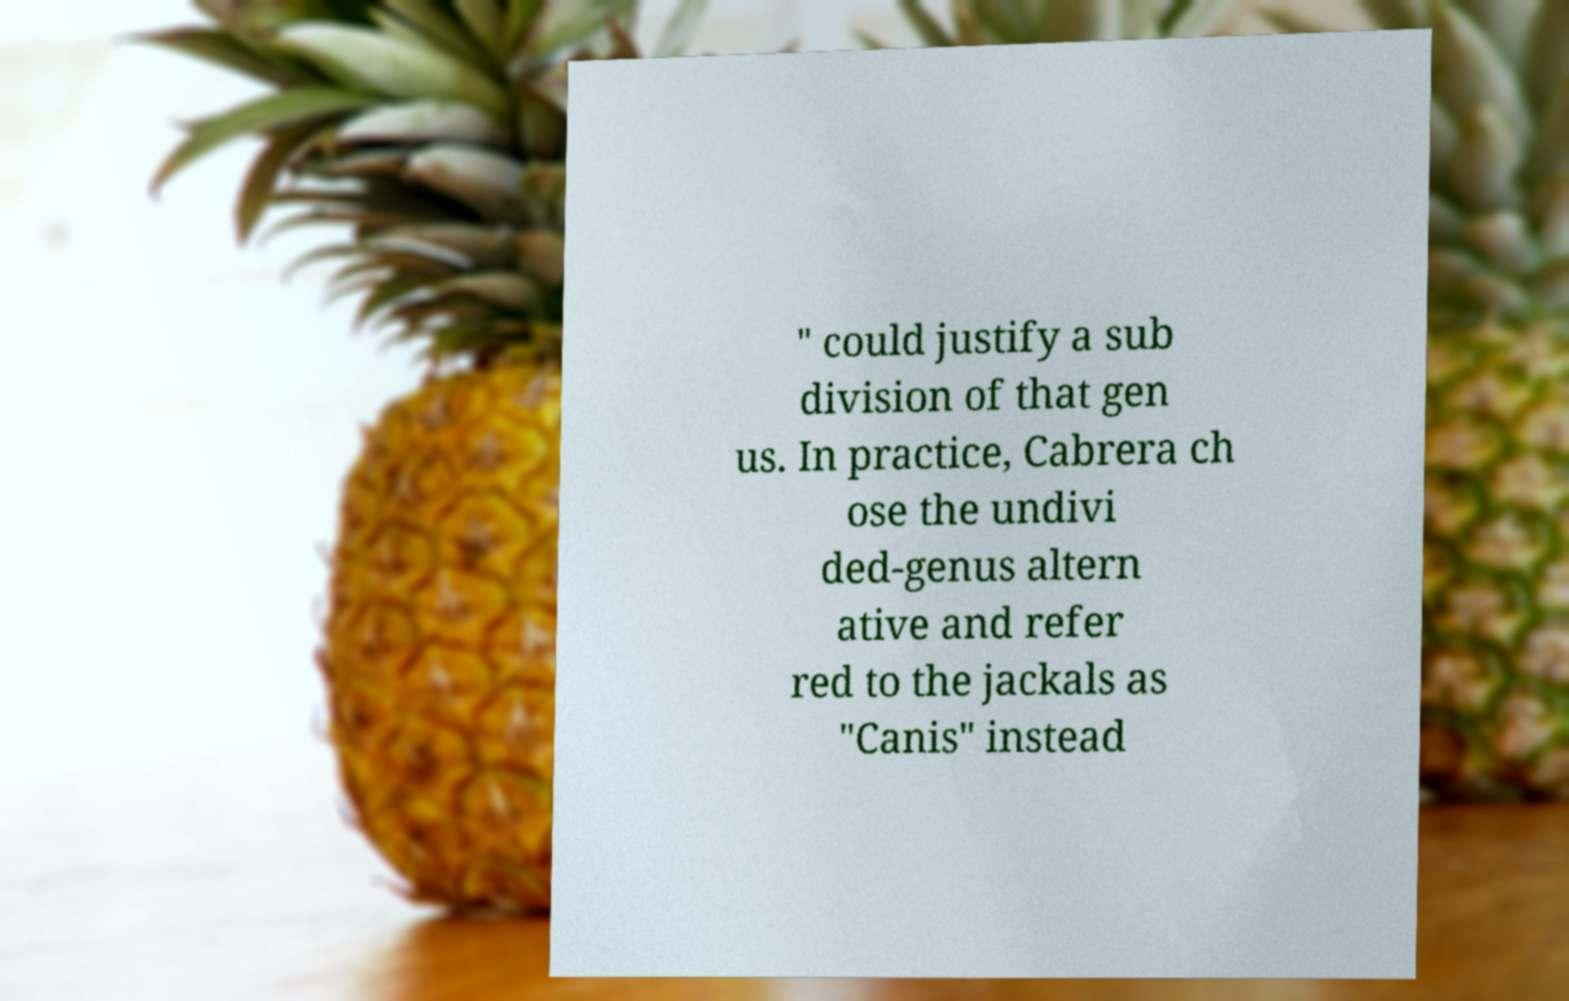Please read and relay the text visible in this image. What does it say? " could justify a sub division of that gen us. In practice, Cabrera ch ose the undivi ded-genus altern ative and refer red to the jackals as "Canis" instead 